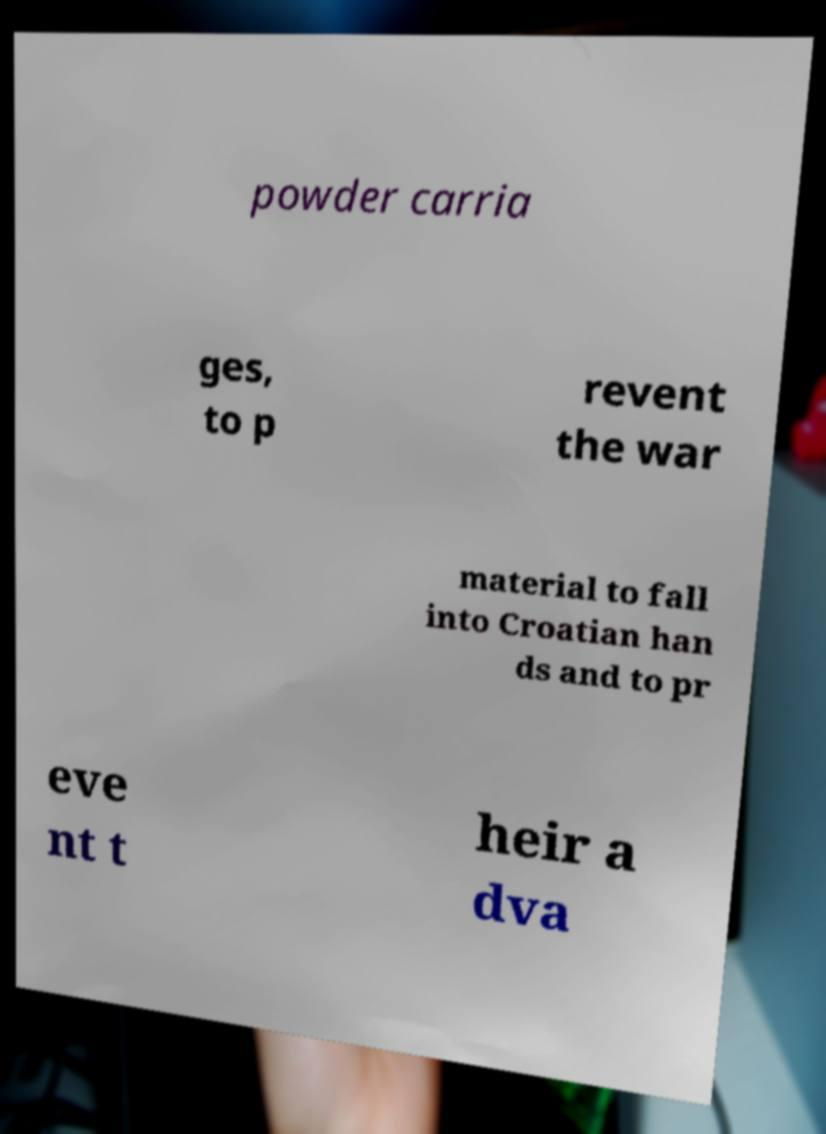Can you accurately transcribe the text from the provided image for me? powder carria ges, to p revent the war material to fall into Croatian han ds and to pr eve nt t heir a dva 